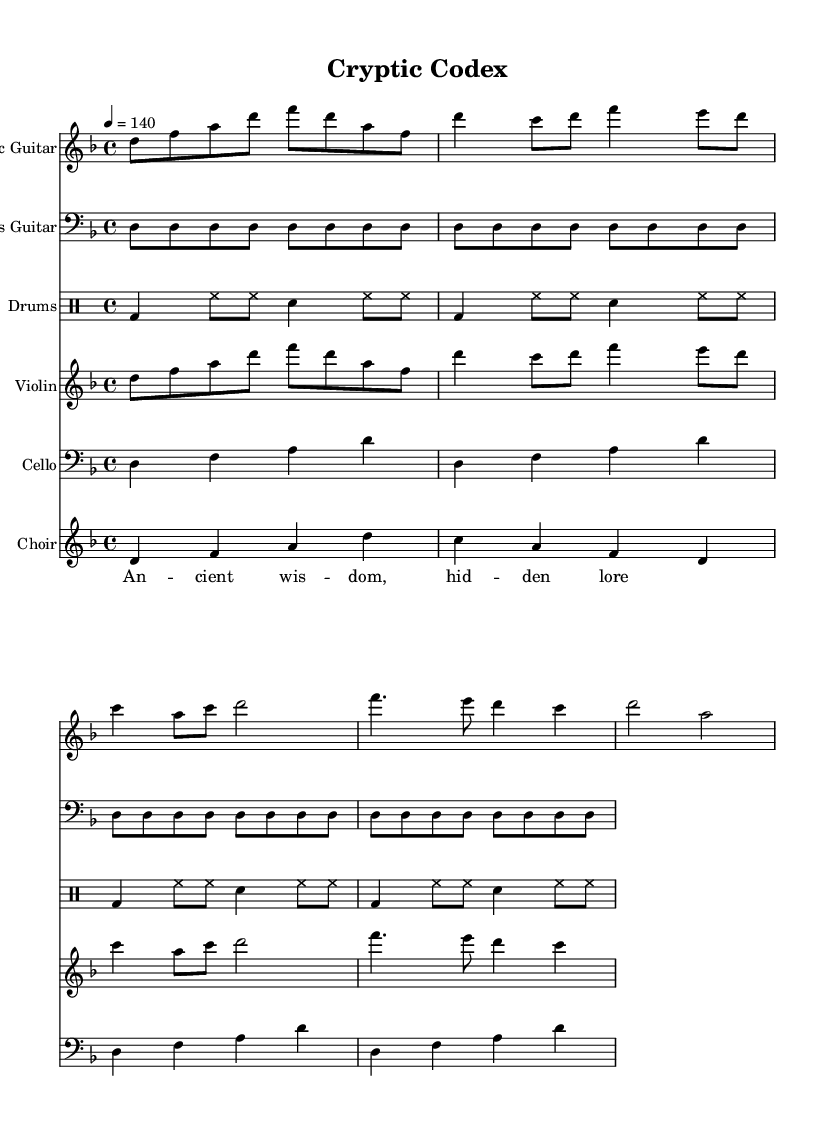What is the key signature of this music? The key signature can be found at the beginning of the staff and indicates two flats. This corresponds to the D minor scale.
Answer: D minor What is the time signature of this music? The time signature is indicated at the beginning of the sheet music, showing four beats per measure, which is written as 4/4.
Answer: 4/4 What is the tempo marking? The tempo marking is specified at the beginning of the score, denoted as "4 = 140", which indicates the metronome marking for the quarter note.
Answer: 140 How many measures are there in the electric guitar part? By counting the number of measures in the electric guitar staff, we find a total of 8 measures, each separated by bar lines, contributing to the overall structure of the piece.
Answer: 8 What is the primary instrument complement in the ensemble? Observing the score, the primary instruments are electric guitar, bass guitar, violin, cello, drums, and choir, highlighting the orchestration typical of symphonic metal. The most prominent is the electric guitar.
Answer: Electric Guitar What is the thematic lyric associated with the choir? The lyrics provided for the choir part convey "Ancient wisdom, hidden lore," which aligns well with the themes of mystery and ancient knowledge often explored in symphonic metal.
Answer: Ancient wisdom, hidden lore 